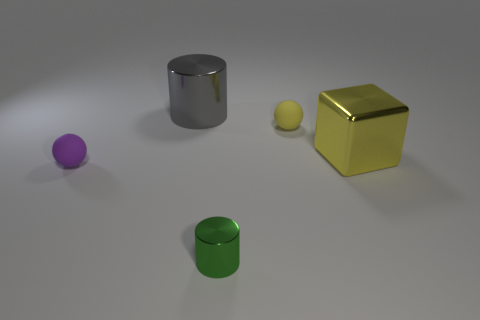There is a sphere in front of the rubber thing right of the cylinder behind the big cube; how big is it?
Ensure brevity in your answer.  Small. There is a small yellow object; are there any tiny yellow spheres behind it?
Your response must be concise. No. What size is the gray object that is the same material as the large block?
Your answer should be very brief. Large. What number of tiny green metallic things have the same shape as the yellow metallic object?
Provide a short and direct response. 0. Is the material of the tiny purple thing the same as the big thing behind the yellow cube?
Give a very brief answer. No. Are there more small rubber balls that are right of the small green shiny object than tiny purple matte objects?
Ensure brevity in your answer.  No. The rubber object that is the same color as the big cube is what shape?
Offer a very short reply. Sphere. Are there any yellow objects that have the same material as the big cylinder?
Provide a short and direct response. Yes. Do the large thing left of the tiny yellow ball and the sphere behind the large yellow cube have the same material?
Offer a terse response. No. Are there an equal number of objects behind the big gray cylinder and cylinders to the right of the yellow metal object?
Keep it short and to the point. Yes. 